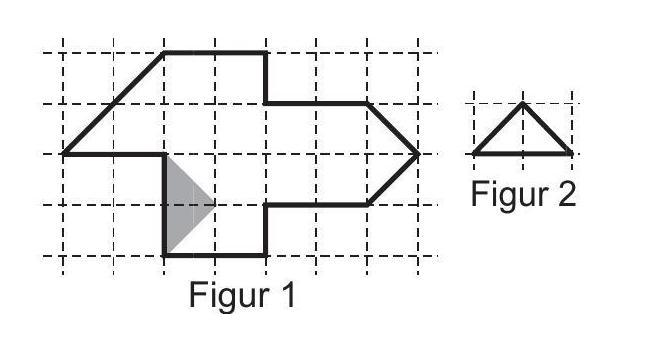What materials would be suitable if Luca wants to create a three-dimensional model based on this two-dimensional diagram? For a three-dimensional project, lightweight materials like foam board or cardboard are excellent choices as they are easy to cut and assemble. For a more durable model, plastic or light wood could be used. Implementing joints or connectors would help in maintaining the structural integrity of the 3D model. 